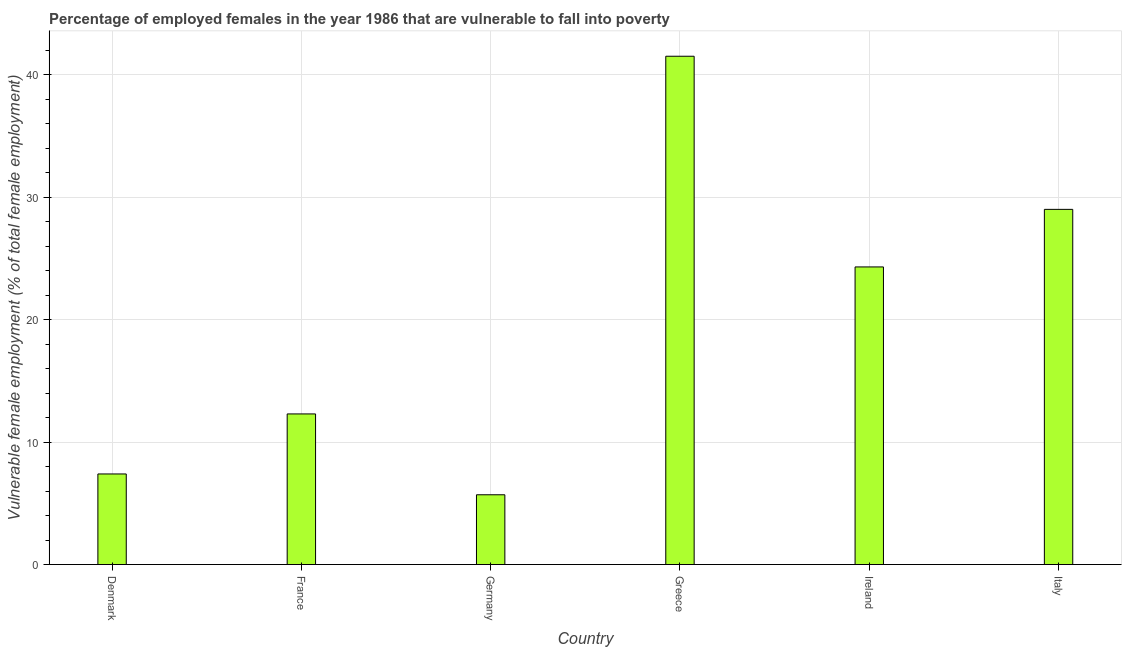Does the graph contain any zero values?
Offer a terse response. No. What is the title of the graph?
Your response must be concise. Percentage of employed females in the year 1986 that are vulnerable to fall into poverty. What is the label or title of the X-axis?
Your answer should be very brief. Country. What is the label or title of the Y-axis?
Provide a short and direct response. Vulnerable female employment (% of total female employment). What is the percentage of employed females who are vulnerable to fall into poverty in Denmark?
Keep it short and to the point. 7.4. Across all countries, what is the maximum percentage of employed females who are vulnerable to fall into poverty?
Your answer should be compact. 41.5. Across all countries, what is the minimum percentage of employed females who are vulnerable to fall into poverty?
Provide a succinct answer. 5.7. What is the sum of the percentage of employed females who are vulnerable to fall into poverty?
Give a very brief answer. 120.2. What is the average percentage of employed females who are vulnerable to fall into poverty per country?
Your answer should be very brief. 20.03. What is the median percentage of employed females who are vulnerable to fall into poverty?
Keep it short and to the point. 18.3. In how many countries, is the percentage of employed females who are vulnerable to fall into poverty greater than 24 %?
Offer a very short reply. 3. What is the ratio of the percentage of employed females who are vulnerable to fall into poverty in France to that in Greece?
Make the answer very short. 0.3. Is the difference between the percentage of employed females who are vulnerable to fall into poverty in Germany and Italy greater than the difference between any two countries?
Your response must be concise. No. What is the difference between the highest and the second highest percentage of employed females who are vulnerable to fall into poverty?
Provide a short and direct response. 12.5. Is the sum of the percentage of employed females who are vulnerable to fall into poverty in Greece and Ireland greater than the maximum percentage of employed females who are vulnerable to fall into poverty across all countries?
Provide a succinct answer. Yes. What is the difference between the highest and the lowest percentage of employed females who are vulnerable to fall into poverty?
Give a very brief answer. 35.8. How many countries are there in the graph?
Make the answer very short. 6. What is the difference between two consecutive major ticks on the Y-axis?
Offer a terse response. 10. What is the Vulnerable female employment (% of total female employment) in Denmark?
Your answer should be very brief. 7.4. What is the Vulnerable female employment (% of total female employment) of France?
Offer a terse response. 12.3. What is the Vulnerable female employment (% of total female employment) in Germany?
Your answer should be very brief. 5.7. What is the Vulnerable female employment (% of total female employment) of Greece?
Your response must be concise. 41.5. What is the Vulnerable female employment (% of total female employment) of Ireland?
Offer a terse response. 24.3. What is the difference between the Vulnerable female employment (% of total female employment) in Denmark and Greece?
Make the answer very short. -34.1. What is the difference between the Vulnerable female employment (% of total female employment) in Denmark and Ireland?
Give a very brief answer. -16.9. What is the difference between the Vulnerable female employment (% of total female employment) in Denmark and Italy?
Your answer should be very brief. -21.6. What is the difference between the Vulnerable female employment (% of total female employment) in France and Greece?
Provide a succinct answer. -29.2. What is the difference between the Vulnerable female employment (% of total female employment) in France and Ireland?
Offer a very short reply. -12. What is the difference between the Vulnerable female employment (% of total female employment) in France and Italy?
Provide a succinct answer. -16.7. What is the difference between the Vulnerable female employment (% of total female employment) in Germany and Greece?
Your answer should be very brief. -35.8. What is the difference between the Vulnerable female employment (% of total female employment) in Germany and Ireland?
Provide a short and direct response. -18.6. What is the difference between the Vulnerable female employment (% of total female employment) in Germany and Italy?
Give a very brief answer. -23.3. What is the ratio of the Vulnerable female employment (% of total female employment) in Denmark to that in France?
Offer a terse response. 0.6. What is the ratio of the Vulnerable female employment (% of total female employment) in Denmark to that in Germany?
Your answer should be very brief. 1.3. What is the ratio of the Vulnerable female employment (% of total female employment) in Denmark to that in Greece?
Offer a very short reply. 0.18. What is the ratio of the Vulnerable female employment (% of total female employment) in Denmark to that in Ireland?
Your response must be concise. 0.3. What is the ratio of the Vulnerable female employment (% of total female employment) in Denmark to that in Italy?
Offer a very short reply. 0.26. What is the ratio of the Vulnerable female employment (% of total female employment) in France to that in Germany?
Ensure brevity in your answer.  2.16. What is the ratio of the Vulnerable female employment (% of total female employment) in France to that in Greece?
Offer a terse response. 0.3. What is the ratio of the Vulnerable female employment (% of total female employment) in France to that in Ireland?
Make the answer very short. 0.51. What is the ratio of the Vulnerable female employment (% of total female employment) in France to that in Italy?
Your response must be concise. 0.42. What is the ratio of the Vulnerable female employment (% of total female employment) in Germany to that in Greece?
Your answer should be very brief. 0.14. What is the ratio of the Vulnerable female employment (% of total female employment) in Germany to that in Ireland?
Offer a very short reply. 0.23. What is the ratio of the Vulnerable female employment (% of total female employment) in Germany to that in Italy?
Ensure brevity in your answer.  0.2. What is the ratio of the Vulnerable female employment (% of total female employment) in Greece to that in Ireland?
Your answer should be compact. 1.71. What is the ratio of the Vulnerable female employment (% of total female employment) in Greece to that in Italy?
Your answer should be very brief. 1.43. What is the ratio of the Vulnerable female employment (% of total female employment) in Ireland to that in Italy?
Provide a short and direct response. 0.84. 